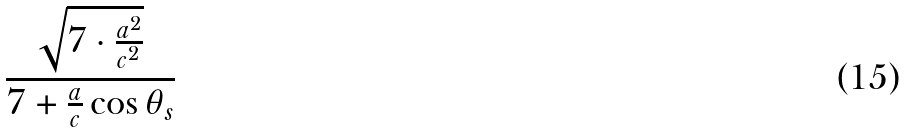Convert formula to latex. <formula><loc_0><loc_0><loc_500><loc_500>\frac { \sqrt { 7 \cdot \frac { a ^ { 2 } } { c ^ { 2 } } } } { 7 + \frac { a } { c } \cos \theta _ { s } }</formula> 